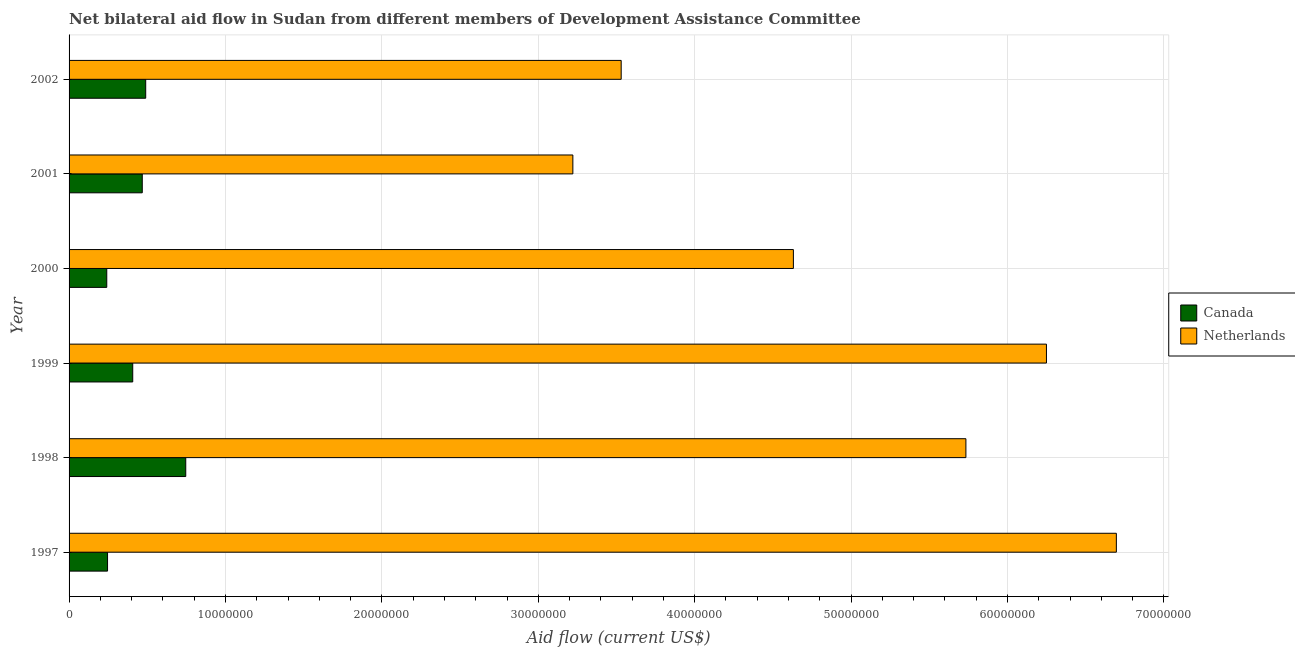How many different coloured bars are there?
Give a very brief answer. 2. Are the number of bars on each tick of the Y-axis equal?
Provide a short and direct response. Yes. How many bars are there on the 1st tick from the bottom?
Your answer should be very brief. 2. In how many cases, is the number of bars for a given year not equal to the number of legend labels?
Ensure brevity in your answer.  0. What is the amount of aid given by canada in 2000?
Provide a succinct answer. 2.41e+06. Across all years, what is the maximum amount of aid given by netherlands?
Offer a terse response. 6.70e+07. Across all years, what is the minimum amount of aid given by canada?
Your answer should be very brief. 2.41e+06. In which year was the amount of aid given by canada maximum?
Your answer should be very brief. 1998. In which year was the amount of aid given by canada minimum?
Give a very brief answer. 2000. What is the total amount of aid given by canada in the graph?
Your answer should be compact. 2.60e+07. What is the difference between the amount of aid given by canada in 1997 and that in 1998?
Give a very brief answer. -5.00e+06. What is the difference between the amount of aid given by canada in 1999 and the amount of aid given by netherlands in 2001?
Provide a short and direct response. -2.81e+07. What is the average amount of aid given by canada per year?
Make the answer very short. 4.33e+06. In the year 2000, what is the difference between the amount of aid given by canada and amount of aid given by netherlands?
Make the answer very short. -4.39e+07. What is the ratio of the amount of aid given by canada in 2000 to that in 2001?
Your answer should be very brief. 0.52. Is the amount of aid given by canada in 1997 less than that in 1998?
Provide a short and direct response. Yes. Is the difference between the amount of aid given by netherlands in 1997 and 2000 greater than the difference between the amount of aid given by canada in 1997 and 2000?
Provide a short and direct response. Yes. What is the difference between the highest and the second highest amount of aid given by netherlands?
Keep it short and to the point. 4.47e+06. What is the difference between the highest and the lowest amount of aid given by canada?
Ensure brevity in your answer.  5.05e+06. In how many years, is the amount of aid given by canada greater than the average amount of aid given by canada taken over all years?
Keep it short and to the point. 3. Is the sum of the amount of aid given by canada in 1998 and 2000 greater than the maximum amount of aid given by netherlands across all years?
Ensure brevity in your answer.  No. What does the 2nd bar from the top in 1997 represents?
Your answer should be very brief. Canada. How many bars are there?
Your answer should be compact. 12. What is the difference between two consecutive major ticks on the X-axis?
Offer a very short reply. 1.00e+07. Are the values on the major ticks of X-axis written in scientific E-notation?
Your response must be concise. No. Does the graph contain grids?
Provide a short and direct response. Yes. Where does the legend appear in the graph?
Offer a very short reply. Center right. How many legend labels are there?
Offer a terse response. 2. How are the legend labels stacked?
Ensure brevity in your answer.  Vertical. What is the title of the graph?
Ensure brevity in your answer.  Net bilateral aid flow in Sudan from different members of Development Assistance Committee. Does "Under-5(female)" appear as one of the legend labels in the graph?
Offer a very short reply. No. What is the Aid flow (current US$) in Canada in 1997?
Offer a terse response. 2.46e+06. What is the Aid flow (current US$) in Netherlands in 1997?
Provide a succinct answer. 6.70e+07. What is the Aid flow (current US$) in Canada in 1998?
Your answer should be compact. 7.46e+06. What is the Aid flow (current US$) in Netherlands in 1998?
Offer a terse response. 5.73e+07. What is the Aid flow (current US$) of Canada in 1999?
Provide a short and direct response. 4.07e+06. What is the Aid flow (current US$) in Netherlands in 1999?
Make the answer very short. 6.25e+07. What is the Aid flow (current US$) of Canada in 2000?
Provide a short and direct response. 2.41e+06. What is the Aid flow (current US$) in Netherlands in 2000?
Provide a succinct answer. 4.63e+07. What is the Aid flow (current US$) in Canada in 2001?
Your response must be concise. 4.68e+06. What is the Aid flow (current US$) of Netherlands in 2001?
Provide a short and direct response. 3.22e+07. What is the Aid flow (current US$) of Canada in 2002?
Offer a very short reply. 4.90e+06. What is the Aid flow (current US$) of Netherlands in 2002?
Provide a short and direct response. 3.53e+07. Across all years, what is the maximum Aid flow (current US$) of Canada?
Ensure brevity in your answer.  7.46e+06. Across all years, what is the maximum Aid flow (current US$) of Netherlands?
Ensure brevity in your answer.  6.70e+07. Across all years, what is the minimum Aid flow (current US$) of Canada?
Provide a short and direct response. 2.41e+06. Across all years, what is the minimum Aid flow (current US$) in Netherlands?
Ensure brevity in your answer.  3.22e+07. What is the total Aid flow (current US$) in Canada in the graph?
Make the answer very short. 2.60e+07. What is the total Aid flow (current US$) of Netherlands in the graph?
Give a very brief answer. 3.01e+08. What is the difference between the Aid flow (current US$) of Canada in 1997 and that in 1998?
Provide a succinct answer. -5.00e+06. What is the difference between the Aid flow (current US$) in Netherlands in 1997 and that in 1998?
Your answer should be very brief. 9.62e+06. What is the difference between the Aid flow (current US$) in Canada in 1997 and that in 1999?
Offer a terse response. -1.61e+06. What is the difference between the Aid flow (current US$) in Netherlands in 1997 and that in 1999?
Give a very brief answer. 4.47e+06. What is the difference between the Aid flow (current US$) of Netherlands in 1997 and that in 2000?
Provide a short and direct response. 2.06e+07. What is the difference between the Aid flow (current US$) in Canada in 1997 and that in 2001?
Provide a succinct answer. -2.22e+06. What is the difference between the Aid flow (current US$) in Netherlands in 1997 and that in 2001?
Provide a short and direct response. 3.48e+07. What is the difference between the Aid flow (current US$) in Canada in 1997 and that in 2002?
Give a very brief answer. -2.44e+06. What is the difference between the Aid flow (current US$) of Netherlands in 1997 and that in 2002?
Keep it short and to the point. 3.17e+07. What is the difference between the Aid flow (current US$) in Canada in 1998 and that in 1999?
Give a very brief answer. 3.39e+06. What is the difference between the Aid flow (current US$) of Netherlands in 1998 and that in 1999?
Provide a short and direct response. -5.15e+06. What is the difference between the Aid flow (current US$) in Canada in 1998 and that in 2000?
Provide a short and direct response. 5.05e+06. What is the difference between the Aid flow (current US$) of Netherlands in 1998 and that in 2000?
Your response must be concise. 1.10e+07. What is the difference between the Aid flow (current US$) in Canada in 1998 and that in 2001?
Your answer should be compact. 2.78e+06. What is the difference between the Aid flow (current US$) in Netherlands in 1998 and that in 2001?
Provide a succinct answer. 2.51e+07. What is the difference between the Aid flow (current US$) of Canada in 1998 and that in 2002?
Give a very brief answer. 2.56e+06. What is the difference between the Aid flow (current US$) of Netherlands in 1998 and that in 2002?
Your answer should be compact. 2.20e+07. What is the difference between the Aid flow (current US$) of Canada in 1999 and that in 2000?
Your answer should be compact. 1.66e+06. What is the difference between the Aid flow (current US$) in Netherlands in 1999 and that in 2000?
Keep it short and to the point. 1.62e+07. What is the difference between the Aid flow (current US$) in Canada in 1999 and that in 2001?
Provide a short and direct response. -6.10e+05. What is the difference between the Aid flow (current US$) of Netherlands in 1999 and that in 2001?
Your answer should be compact. 3.03e+07. What is the difference between the Aid flow (current US$) of Canada in 1999 and that in 2002?
Your answer should be very brief. -8.30e+05. What is the difference between the Aid flow (current US$) of Netherlands in 1999 and that in 2002?
Provide a succinct answer. 2.72e+07. What is the difference between the Aid flow (current US$) in Canada in 2000 and that in 2001?
Keep it short and to the point. -2.27e+06. What is the difference between the Aid flow (current US$) of Netherlands in 2000 and that in 2001?
Make the answer very short. 1.41e+07. What is the difference between the Aid flow (current US$) of Canada in 2000 and that in 2002?
Keep it short and to the point. -2.49e+06. What is the difference between the Aid flow (current US$) of Netherlands in 2000 and that in 2002?
Make the answer very short. 1.10e+07. What is the difference between the Aid flow (current US$) in Canada in 2001 and that in 2002?
Ensure brevity in your answer.  -2.20e+05. What is the difference between the Aid flow (current US$) in Netherlands in 2001 and that in 2002?
Your answer should be very brief. -3.09e+06. What is the difference between the Aid flow (current US$) in Canada in 1997 and the Aid flow (current US$) in Netherlands in 1998?
Give a very brief answer. -5.49e+07. What is the difference between the Aid flow (current US$) in Canada in 1997 and the Aid flow (current US$) in Netherlands in 1999?
Your answer should be very brief. -6.00e+07. What is the difference between the Aid flow (current US$) of Canada in 1997 and the Aid flow (current US$) of Netherlands in 2000?
Your answer should be compact. -4.38e+07. What is the difference between the Aid flow (current US$) of Canada in 1997 and the Aid flow (current US$) of Netherlands in 2001?
Make the answer very short. -2.98e+07. What is the difference between the Aid flow (current US$) of Canada in 1997 and the Aid flow (current US$) of Netherlands in 2002?
Keep it short and to the point. -3.28e+07. What is the difference between the Aid flow (current US$) of Canada in 1998 and the Aid flow (current US$) of Netherlands in 1999?
Provide a succinct answer. -5.50e+07. What is the difference between the Aid flow (current US$) of Canada in 1998 and the Aid flow (current US$) of Netherlands in 2000?
Ensure brevity in your answer.  -3.88e+07. What is the difference between the Aid flow (current US$) in Canada in 1998 and the Aid flow (current US$) in Netherlands in 2001?
Your response must be concise. -2.48e+07. What is the difference between the Aid flow (current US$) of Canada in 1998 and the Aid flow (current US$) of Netherlands in 2002?
Your answer should be very brief. -2.78e+07. What is the difference between the Aid flow (current US$) in Canada in 1999 and the Aid flow (current US$) in Netherlands in 2000?
Make the answer very short. -4.22e+07. What is the difference between the Aid flow (current US$) in Canada in 1999 and the Aid flow (current US$) in Netherlands in 2001?
Your response must be concise. -2.81e+07. What is the difference between the Aid flow (current US$) of Canada in 1999 and the Aid flow (current US$) of Netherlands in 2002?
Your response must be concise. -3.12e+07. What is the difference between the Aid flow (current US$) in Canada in 2000 and the Aid flow (current US$) in Netherlands in 2001?
Offer a very short reply. -2.98e+07. What is the difference between the Aid flow (current US$) of Canada in 2000 and the Aid flow (current US$) of Netherlands in 2002?
Your answer should be very brief. -3.29e+07. What is the difference between the Aid flow (current US$) in Canada in 2001 and the Aid flow (current US$) in Netherlands in 2002?
Your answer should be very brief. -3.06e+07. What is the average Aid flow (current US$) in Canada per year?
Provide a succinct answer. 4.33e+06. What is the average Aid flow (current US$) in Netherlands per year?
Your response must be concise. 5.01e+07. In the year 1997, what is the difference between the Aid flow (current US$) of Canada and Aid flow (current US$) of Netherlands?
Provide a succinct answer. -6.45e+07. In the year 1998, what is the difference between the Aid flow (current US$) of Canada and Aid flow (current US$) of Netherlands?
Provide a short and direct response. -4.99e+07. In the year 1999, what is the difference between the Aid flow (current US$) of Canada and Aid flow (current US$) of Netherlands?
Offer a terse response. -5.84e+07. In the year 2000, what is the difference between the Aid flow (current US$) in Canada and Aid flow (current US$) in Netherlands?
Offer a terse response. -4.39e+07. In the year 2001, what is the difference between the Aid flow (current US$) of Canada and Aid flow (current US$) of Netherlands?
Offer a very short reply. -2.75e+07. In the year 2002, what is the difference between the Aid flow (current US$) in Canada and Aid flow (current US$) in Netherlands?
Make the answer very short. -3.04e+07. What is the ratio of the Aid flow (current US$) of Canada in 1997 to that in 1998?
Your answer should be compact. 0.33. What is the ratio of the Aid flow (current US$) in Netherlands in 1997 to that in 1998?
Ensure brevity in your answer.  1.17. What is the ratio of the Aid flow (current US$) in Canada in 1997 to that in 1999?
Make the answer very short. 0.6. What is the ratio of the Aid flow (current US$) in Netherlands in 1997 to that in 1999?
Keep it short and to the point. 1.07. What is the ratio of the Aid flow (current US$) in Canada in 1997 to that in 2000?
Ensure brevity in your answer.  1.02. What is the ratio of the Aid flow (current US$) in Netherlands in 1997 to that in 2000?
Provide a short and direct response. 1.45. What is the ratio of the Aid flow (current US$) in Canada in 1997 to that in 2001?
Make the answer very short. 0.53. What is the ratio of the Aid flow (current US$) in Netherlands in 1997 to that in 2001?
Make the answer very short. 2.08. What is the ratio of the Aid flow (current US$) of Canada in 1997 to that in 2002?
Provide a succinct answer. 0.5. What is the ratio of the Aid flow (current US$) in Netherlands in 1997 to that in 2002?
Your answer should be compact. 1.9. What is the ratio of the Aid flow (current US$) of Canada in 1998 to that in 1999?
Give a very brief answer. 1.83. What is the ratio of the Aid flow (current US$) in Netherlands in 1998 to that in 1999?
Offer a terse response. 0.92. What is the ratio of the Aid flow (current US$) in Canada in 1998 to that in 2000?
Your answer should be compact. 3.1. What is the ratio of the Aid flow (current US$) in Netherlands in 1998 to that in 2000?
Provide a short and direct response. 1.24. What is the ratio of the Aid flow (current US$) in Canada in 1998 to that in 2001?
Ensure brevity in your answer.  1.59. What is the ratio of the Aid flow (current US$) in Netherlands in 1998 to that in 2001?
Your answer should be compact. 1.78. What is the ratio of the Aid flow (current US$) of Canada in 1998 to that in 2002?
Your answer should be very brief. 1.52. What is the ratio of the Aid flow (current US$) in Netherlands in 1998 to that in 2002?
Offer a terse response. 1.62. What is the ratio of the Aid flow (current US$) in Canada in 1999 to that in 2000?
Your answer should be very brief. 1.69. What is the ratio of the Aid flow (current US$) in Netherlands in 1999 to that in 2000?
Provide a succinct answer. 1.35. What is the ratio of the Aid flow (current US$) of Canada in 1999 to that in 2001?
Make the answer very short. 0.87. What is the ratio of the Aid flow (current US$) of Netherlands in 1999 to that in 2001?
Ensure brevity in your answer.  1.94. What is the ratio of the Aid flow (current US$) of Canada in 1999 to that in 2002?
Offer a terse response. 0.83. What is the ratio of the Aid flow (current US$) in Netherlands in 1999 to that in 2002?
Keep it short and to the point. 1.77. What is the ratio of the Aid flow (current US$) of Canada in 2000 to that in 2001?
Keep it short and to the point. 0.52. What is the ratio of the Aid flow (current US$) in Netherlands in 2000 to that in 2001?
Make the answer very short. 1.44. What is the ratio of the Aid flow (current US$) in Canada in 2000 to that in 2002?
Your response must be concise. 0.49. What is the ratio of the Aid flow (current US$) in Netherlands in 2000 to that in 2002?
Make the answer very short. 1.31. What is the ratio of the Aid flow (current US$) of Canada in 2001 to that in 2002?
Provide a short and direct response. 0.96. What is the ratio of the Aid flow (current US$) in Netherlands in 2001 to that in 2002?
Your response must be concise. 0.91. What is the difference between the highest and the second highest Aid flow (current US$) of Canada?
Offer a terse response. 2.56e+06. What is the difference between the highest and the second highest Aid flow (current US$) in Netherlands?
Your answer should be compact. 4.47e+06. What is the difference between the highest and the lowest Aid flow (current US$) in Canada?
Your answer should be very brief. 5.05e+06. What is the difference between the highest and the lowest Aid flow (current US$) of Netherlands?
Provide a succinct answer. 3.48e+07. 